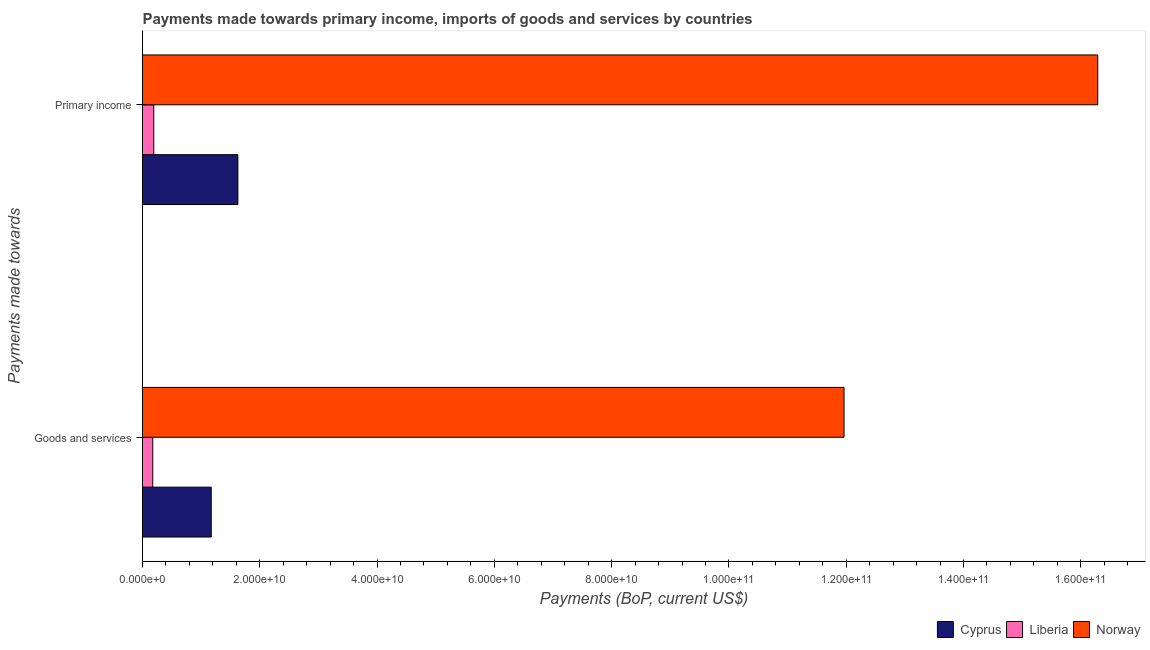How many different coloured bars are there?
Provide a succinct answer. 3. Are the number of bars per tick equal to the number of legend labels?
Offer a terse response. Yes. What is the label of the 1st group of bars from the top?
Your answer should be compact. Primary income. What is the payments made towards primary income in Liberia?
Your answer should be compact. 1.92e+09. Across all countries, what is the maximum payments made towards goods and services?
Your answer should be compact. 1.20e+11. Across all countries, what is the minimum payments made towards primary income?
Offer a terse response. 1.92e+09. In which country was the payments made towards goods and services minimum?
Provide a short and direct response. Liberia. What is the total payments made towards primary income in the graph?
Offer a very short reply. 1.81e+11. What is the difference between the payments made towards primary income in Cyprus and that in Liberia?
Offer a very short reply. 1.43e+1. What is the difference between the payments made towards primary income in Norway and the payments made towards goods and services in Liberia?
Your response must be concise. 1.61e+11. What is the average payments made towards primary income per country?
Your answer should be very brief. 6.04e+1. What is the difference between the payments made towards goods and services and payments made towards primary income in Norway?
Make the answer very short. -4.33e+1. What is the ratio of the payments made towards goods and services in Liberia to that in Cyprus?
Provide a succinct answer. 0.15. Is the payments made towards goods and services in Liberia less than that in Cyprus?
Give a very brief answer. Yes. What does the 1st bar from the top in Goods and services represents?
Your response must be concise. Norway. What does the 2nd bar from the bottom in Goods and services represents?
Keep it short and to the point. Liberia. How many bars are there?
Your response must be concise. 6. Are all the bars in the graph horizontal?
Your answer should be compact. Yes. How many countries are there in the graph?
Offer a very short reply. 3. Are the values on the major ticks of X-axis written in scientific E-notation?
Provide a succinct answer. Yes. How are the legend labels stacked?
Provide a short and direct response. Horizontal. What is the title of the graph?
Your answer should be compact. Payments made towards primary income, imports of goods and services by countries. Does "Guam" appear as one of the legend labels in the graph?
Ensure brevity in your answer.  No. What is the label or title of the X-axis?
Your response must be concise. Payments (BoP, current US$). What is the label or title of the Y-axis?
Provide a succinct answer. Payments made towards. What is the Payments (BoP, current US$) of Cyprus in Goods and services?
Your response must be concise. 1.17e+1. What is the Payments (BoP, current US$) of Liberia in Goods and services?
Provide a succinct answer. 1.75e+09. What is the Payments (BoP, current US$) in Norway in Goods and services?
Provide a succinct answer. 1.20e+11. What is the Payments (BoP, current US$) of Cyprus in Primary income?
Provide a succinct answer. 1.63e+1. What is the Payments (BoP, current US$) in Liberia in Primary income?
Offer a very short reply. 1.92e+09. What is the Payments (BoP, current US$) of Norway in Primary income?
Keep it short and to the point. 1.63e+11. Across all Payments made towards, what is the maximum Payments (BoP, current US$) of Cyprus?
Your answer should be very brief. 1.63e+1. Across all Payments made towards, what is the maximum Payments (BoP, current US$) of Liberia?
Your response must be concise. 1.92e+09. Across all Payments made towards, what is the maximum Payments (BoP, current US$) of Norway?
Make the answer very short. 1.63e+11. Across all Payments made towards, what is the minimum Payments (BoP, current US$) of Cyprus?
Your response must be concise. 1.17e+1. Across all Payments made towards, what is the minimum Payments (BoP, current US$) in Liberia?
Offer a very short reply. 1.75e+09. Across all Payments made towards, what is the minimum Payments (BoP, current US$) in Norway?
Make the answer very short. 1.20e+11. What is the total Payments (BoP, current US$) of Cyprus in the graph?
Your response must be concise. 2.80e+1. What is the total Payments (BoP, current US$) of Liberia in the graph?
Keep it short and to the point. 3.67e+09. What is the total Payments (BoP, current US$) of Norway in the graph?
Make the answer very short. 2.83e+11. What is the difference between the Payments (BoP, current US$) of Cyprus in Goods and services and that in Primary income?
Provide a short and direct response. -4.55e+09. What is the difference between the Payments (BoP, current US$) in Liberia in Goods and services and that in Primary income?
Give a very brief answer. -1.77e+08. What is the difference between the Payments (BoP, current US$) of Norway in Goods and services and that in Primary income?
Your answer should be compact. -4.33e+1. What is the difference between the Payments (BoP, current US$) of Cyprus in Goods and services and the Payments (BoP, current US$) of Liberia in Primary income?
Your answer should be compact. 9.80e+09. What is the difference between the Payments (BoP, current US$) in Cyprus in Goods and services and the Payments (BoP, current US$) in Norway in Primary income?
Provide a succinct answer. -1.51e+11. What is the difference between the Payments (BoP, current US$) in Liberia in Goods and services and the Payments (BoP, current US$) in Norway in Primary income?
Make the answer very short. -1.61e+11. What is the average Payments (BoP, current US$) in Cyprus per Payments made towards?
Give a very brief answer. 1.40e+1. What is the average Payments (BoP, current US$) of Liberia per Payments made towards?
Provide a succinct answer. 1.84e+09. What is the average Payments (BoP, current US$) of Norway per Payments made towards?
Give a very brief answer. 1.41e+11. What is the difference between the Payments (BoP, current US$) in Cyprus and Payments (BoP, current US$) in Liberia in Goods and services?
Offer a very short reply. 9.97e+09. What is the difference between the Payments (BoP, current US$) of Cyprus and Payments (BoP, current US$) of Norway in Goods and services?
Provide a succinct answer. -1.08e+11. What is the difference between the Payments (BoP, current US$) in Liberia and Payments (BoP, current US$) in Norway in Goods and services?
Make the answer very short. -1.18e+11. What is the difference between the Payments (BoP, current US$) of Cyprus and Payments (BoP, current US$) of Liberia in Primary income?
Make the answer very short. 1.43e+1. What is the difference between the Payments (BoP, current US$) of Cyprus and Payments (BoP, current US$) of Norway in Primary income?
Keep it short and to the point. -1.47e+11. What is the difference between the Payments (BoP, current US$) of Liberia and Payments (BoP, current US$) of Norway in Primary income?
Your response must be concise. -1.61e+11. What is the ratio of the Payments (BoP, current US$) in Cyprus in Goods and services to that in Primary income?
Provide a succinct answer. 0.72. What is the ratio of the Payments (BoP, current US$) in Liberia in Goods and services to that in Primary income?
Your response must be concise. 0.91. What is the ratio of the Payments (BoP, current US$) of Norway in Goods and services to that in Primary income?
Make the answer very short. 0.73. What is the difference between the highest and the second highest Payments (BoP, current US$) in Cyprus?
Keep it short and to the point. 4.55e+09. What is the difference between the highest and the second highest Payments (BoP, current US$) in Liberia?
Keep it short and to the point. 1.77e+08. What is the difference between the highest and the second highest Payments (BoP, current US$) in Norway?
Your answer should be compact. 4.33e+1. What is the difference between the highest and the lowest Payments (BoP, current US$) of Cyprus?
Make the answer very short. 4.55e+09. What is the difference between the highest and the lowest Payments (BoP, current US$) in Liberia?
Keep it short and to the point. 1.77e+08. What is the difference between the highest and the lowest Payments (BoP, current US$) of Norway?
Provide a succinct answer. 4.33e+1. 